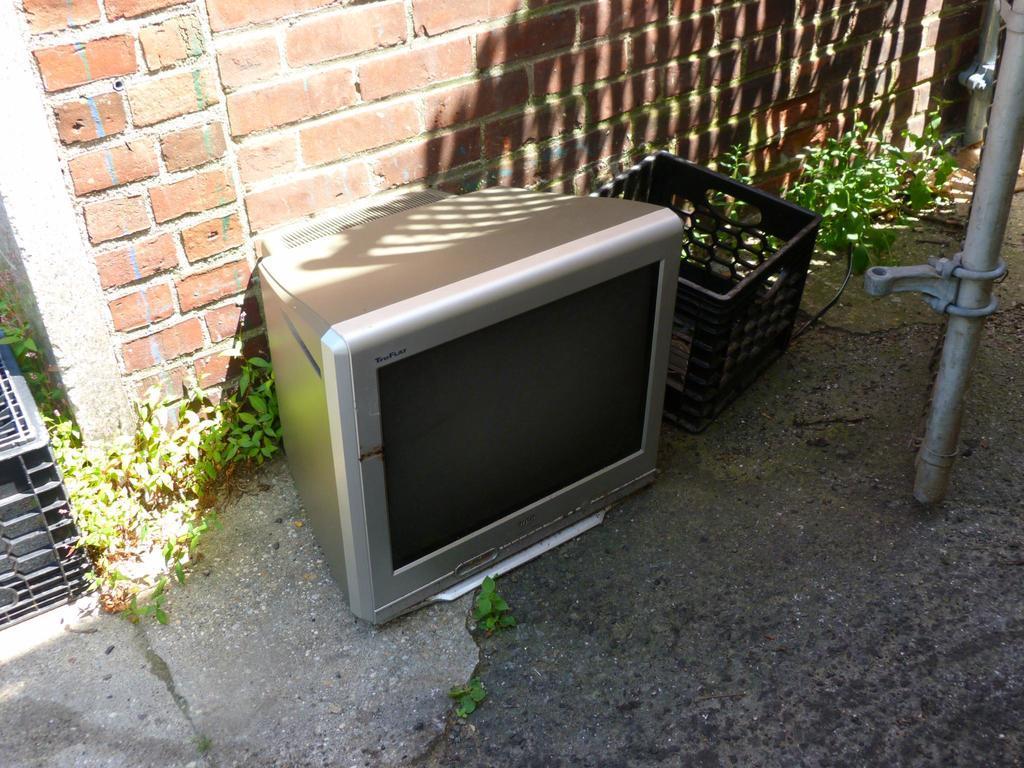Describe this image in one or two sentences. In this picture there is a television which is kept on the floor, beside that I can see the basket and grass. In the back I can see the brick wall. On the right I can see the pipe. 